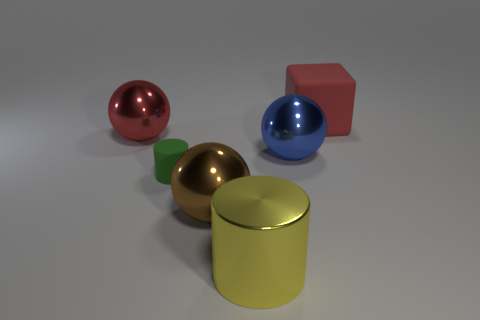Add 2 red matte things. How many objects exist? 8 Subtract all cubes. How many objects are left? 5 Subtract 0 purple spheres. How many objects are left? 6 Subtract all green balls. Subtract all yellow cylinders. How many objects are left? 5 Add 5 spheres. How many spheres are left? 8 Add 2 brown spheres. How many brown spheres exist? 3 